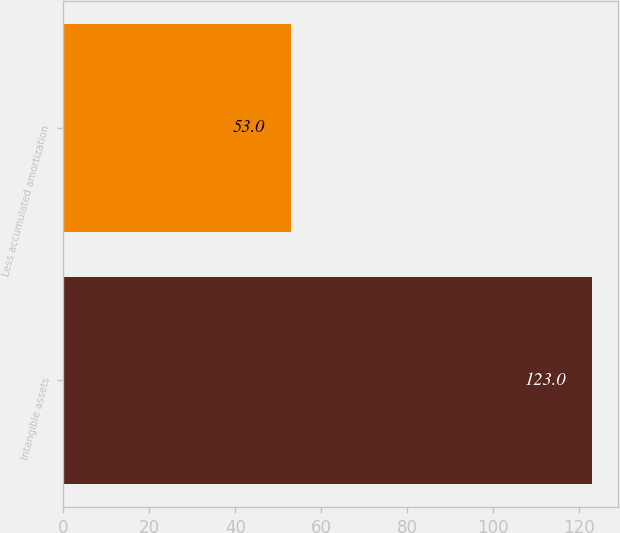Convert chart to OTSL. <chart><loc_0><loc_0><loc_500><loc_500><bar_chart><fcel>Intangible assets<fcel>Less accumulated amortization<nl><fcel>123<fcel>53<nl></chart> 